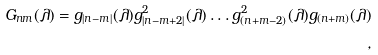<formula> <loc_0><loc_0><loc_500><loc_500>G _ { n m } ( \lambda ) = g _ { | n - m | } ( \lambda ) g _ { | n - m + 2 | } ^ { 2 } ( \lambda ) \dots g _ { ( n + m - 2 ) } ^ { 2 } ( \lambda ) g _ { ( n + m ) } ( \lambda ) \\ ,</formula> 